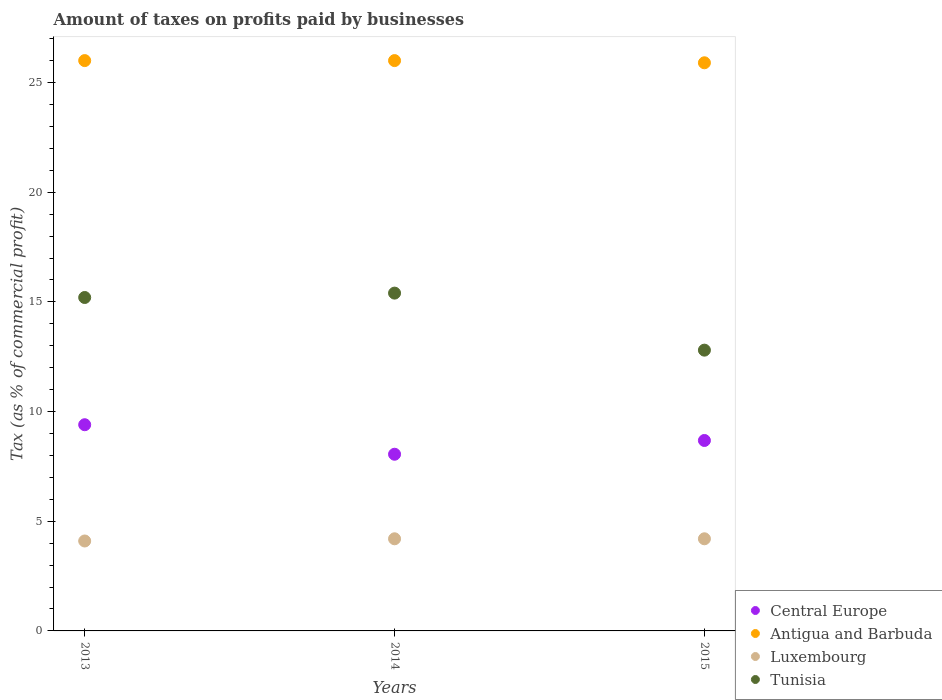What is the percentage of taxes paid by businesses in Central Europe in 2014?
Offer a very short reply. 8.05. Across all years, what is the maximum percentage of taxes paid by businesses in Tunisia?
Provide a short and direct response. 15.4. Across all years, what is the minimum percentage of taxes paid by businesses in Tunisia?
Your answer should be compact. 12.8. In which year was the percentage of taxes paid by businesses in Antigua and Barbuda minimum?
Keep it short and to the point. 2015. What is the difference between the percentage of taxes paid by businesses in Antigua and Barbuda in 2014 and that in 2015?
Your response must be concise. 0.1. What is the difference between the percentage of taxes paid by businesses in Tunisia in 2013 and the percentage of taxes paid by businesses in Central Europe in 2014?
Keep it short and to the point. 7.15. What is the average percentage of taxes paid by businesses in Luxembourg per year?
Offer a terse response. 4.17. In the year 2015, what is the difference between the percentage of taxes paid by businesses in Tunisia and percentage of taxes paid by businesses in Luxembourg?
Make the answer very short. 8.6. What is the ratio of the percentage of taxes paid by businesses in Tunisia in 2014 to that in 2015?
Your response must be concise. 1.2. Is the percentage of taxes paid by businesses in Antigua and Barbuda in 2014 less than that in 2015?
Ensure brevity in your answer.  No. Is the difference between the percentage of taxes paid by businesses in Tunisia in 2014 and 2015 greater than the difference between the percentage of taxes paid by businesses in Luxembourg in 2014 and 2015?
Your response must be concise. Yes. What is the difference between the highest and the lowest percentage of taxes paid by businesses in Tunisia?
Make the answer very short. 2.6. In how many years, is the percentage of taxes paid by businesses in Luxembourg greater than the average percentage of taxes paid by businesses in Luxembourg taken over all years?
Make the answer very short. 2. Is it the case that in every year, the sum of the percentage of taxes paid by businesses in Antigua and Barbuda and percentage of taxes paid by businesses in Luxembourg  is greater than the percentage of taxes paid by businesses in Central Europe?
Provide a short and direct response. Yes. Does the percentage of taxes paid by businesses in Central Europe monotonically increase over the years?
Make the answer very short. No. Is the percentage of taxes paid by businesses in Tunisia strictly greater than the percentage of taxes paid by businesses in Antigua and Barbuda over the years?
Your answer should be compact. No. How many dotlines are there?
Provide a succinct answer. 4. How many years are there in the graph?
Offer a very short reply. 3. What is the difference between two consecutive major ticks on the Y-axis?
Your response must be concise. 5. How are the legend labels stacked?
Provide a short and direct response. Vertical. What is the title of the graph?
Ensure brevity in your answer.  Amount of taxes on profits paid by businesses. What is the label or title of the Y-axis?
Provide a succinct answer. Tax (as % of commercial profit). What is the Tax (as % of commercial profit) in Central Europe in 2013?
Provide a succinct answer. 9.4. What is the Tax (as % of commercial profit) in Antigua and Barbuda in 2013?
Keep it short and to the point. 26. What is the Tax (as % of commercial profit) of Central Europe in 2014?
Keep it short and to the point. 8.05. What is the Tax (as % of commercial profit) of Antigua and Barbuda in 2014?
Offer a terse response. 26. What is the Tax (as % of commercial profit) of Luxembourg in 2014?
Make the answer very short. 4.2. What is the Tax (as % of commercial profit) of Tunisia in 2014?
Ensure brevity in your answer.  15.4. What is the Tax (as % of commercial profit) of Central Europe in 2015?
Your answer should be very brief. 8.68. What is the Tax (as % of commercial profit) of Antigua and Barbuda in 2015?
Offer a terse response. 25.9. What is the Tax (as % of commercial profit) in Luxembourg in 2015?
Offer a very short reply. 4.2. What is the Tax (as % of commercial profit) in Tunisia in 2015?
Provide a succinct answer. 12.8. Across all years, what is the maximum Tax (as % of commercial profit) in Antigua and Barbuda?
Keep it short and to the point. 26. Across all years, what is the minimum Tax (as % of commercial profit) of Central Europe?
Keep it short and to the point. 8.05. Across all years, what is the minimum Tax (as % of commercial profit) of Antigua and Barbuda?
Make the answer very short. 25.9. Across all years, what is the minimum Tax (as % of commercial profit) of Luxembourg?
Your answer should be very brief. 4.1. What is the total Tax (as % of commercial profit) in Central Europe in the graph?
Offer a very short reply. 26.14. What is the total Tax (as % of commercial profit) in Antigua and Barbuda in the graph?
Provide a succinct answer. 77.9. What is the total Tax (as % of commercial profit) of Tunisia in the graph?
Your answer should be compact. 43.4. What is the difference between the Tax (as % of commercial profit) in Central Europe in 2013 and that in 2014?
Offer a very short reply. 1.35. What is the difference between the Tax (as % of commercial profit) of Antigua and Barbuda in 2013 and that in 2014?
Give a very brief answer. 0. What is the difference between the Tax (as % of commercial profit) in Luxembourg in 2013 and that in 2014?
Your answer should be very brief. -0.1. What is the difference between the Tax (as % of commercial profit) in Tunisia in 2013 and that in 2014?
Offer a terse response. -0.2. What is the difference between the Tax (as % of commercial profit) of Central Europe in 2013 and that in 2015?
Your answer should be very brief. 0.72. What is the difference between the Tax (as % of commercial profit) in Luxembourg in 2013 and that in 2015?
Provide a succinct answer. -0.1. What is the difference between the Tax (as % of commercial profit) of Central Europe in 2014 and that in 2015?
Provide a succinct answer. -0.63. What is the difference between the Tax (as % of commercial profit) of Tunisia in 2014 and that in 2015?
Your answer should be compact. 2.6. What is the difference between the Tax (as % of commercial profit) in Central Europe in 2013 and the Tax (as % of commercial profit) in Antigua and Barbuda in 2014?
Make the answer very short. -16.6. What is the difference between the Tax (as % of commercial profit) of Central Europe in 2013 and the Tax (as % of commercial profit) of Luxembourg in 2014?
Keep it short and to the point. 5.2. What is the difference between the Tax (as % of commercial profit) in Antigua and Barbuda in 2013 and the Tax (as % of commercial profit) in Luxembourg in 2014?
Provide a short and direct response. 21.8. What is the difference between the Tax (as % of commercial profit) of Antigua and Barbuda in 2013 and the Tax (as % of commercial profit) of Tunisia in 2014?
Make the answer very short. 10.6. What is the difference between the Tax (as % of commercial profit) in Luxembourg in 2013 and the Tax (as % of commercial profit) in Tunisia in 2014?
Provide a short and direct response. -11.3. What is the difference between the Tax (as % of commercial profit) in Central Europe in 2013 and the Tax (as % of commercial profit) in Antigua and Barbuda in 2015?
Offer a terse response. -16.5. What is the difference between the Tax (as % of commercial profit) of Central Europe in 2013 and the Tax (as % of commercial profit) of Tunisia in 2015?
Provide a succinct answer. -3.4. What is the difference between the Tax (as % of commercial profit) of Antigua and Barbuda in 2013 and the Tax (as % of commercial profit) of Luxembourg in 2015?
Offer a very short reply. 21.8. What is the difference between the Tax (as % of commercial profit) of Luxembourg in 2013 and the Tax (as % of commercial profit) of Tunisia in 2015?
Your answer should be very brief. -8.7. What is the difference between the Tax (as % of commercial profit) of Central Europe in 2014 and the Tax (as % of commercial profit) of Antigua and Barbuda in 2015?
Ensure brevity in your answer.  -17.85. What is the difference between the Tax (as % of commercial profit) of Central Europe in 2014 and the Tax (as % of commercial profit) of Luxembourg in 2015?
Give a very brief answer. 3.85. What is the difference between the Tax (as % of commercial profit) of Central Europe in 2014 and the Tax (as % of commercial profit) of Tunisia in 2015?
Keep it short and to the point. -4.75. What is the difference between the Tax (as % of commercial profit) in Antigua and Barbuda in 2014 and the Tax (as % of commercial profit) in Luxembourg in 2015?
Ensure brevity in your answer.  21.8. What is the difference between the Tax (as % of commercial profit) of Luxembourg in 2014 and the Tax (as % of commercial profit) of Tunisia in 2015?
Make the answer very short. -8.6. What is the average Tax (as % of commercial profit) of Central Europe per year?
Your response must be concise. 8.71. What is the average Tax (as % of commercial profit) in Antigua and Barbuda per year?
Your answer should be compact. 25.97. What is the average Tax (as % of commercial profit) in Luxembourg per year?
Give a very brief answer. 4.17. What is the average Tax (as % of commercial profit) of Tunisia per year?
Offer a very short reply. 14.47. In the year 2013, what is the difference between the Tax (as % of commercial profit) of Central Europe and Tax (as % of commercial profit) of Antigua and Barbuda?
Your answer should be very brief. -16.6. In the year 2013, what is the difference between the Tax (as % of commercial profit) of Antigua and Barbuda and Tax (as % of commercial profit) of Luxembourg?
Make the answer very short. 21.9. In the year 2013, what is the difference between the Tax (as % of commercial profit) of Antigua and Barbuda and Tax (as % of commercial profit) of Tunisia?
Offer a terse response. 10.8. In the year 2014, what is the difference between the Tax (as % of commercial profit) in Central Europe and Tax (as % of commercial profit) in Antigua and Barbuda?
Offer a very short reply. -17.95. In the year 2014, what is the difference between the Tax (as % of commercial profit) of Central Europe and Tax (as % of commercial profit) of Luxembourg?
Your response must be concise. 3.85. In the year 2014, what is the difference between the Tax (as % of commercial profit) in Central Europe and Tax (as % of commercial profit) in Tunisia?
Provide a short and direct response. -7.35. In the year 2014, what is the difference between the Tax (as % of commercial profit) of Antigua and Barbuda and Tax (as % of commercial profit) of Luxembourg?
Provide a succinct answer. 21.8. In the year 2014, what is the difference between the Tax (as % of commercial profit) of Luxembourg and Tax (as % of commercial profit) of Tunisia?
Offer a very short reply. -11.2. In the year 2015, what is the difference between the Tax (as % of commercial profit) in Central Europe and Tax (as % of commercial profit) in Antigua and Barbuda?
Your response must be concise. -17.22. In the year 2015, what is the difference between the Tax (as % of commercial profit) of Central Europe and Tax (as % of commercial profit) of Luxembourg?
Your response must be concise. 4.48. In the year 2015, what is the difference between the Tax (as % of commercial profit) in Central Europe and Tax (as % of commercial profit) in Tunisia?
Your answer should be compact. -4.12. In the year 2015, what is the difference between the Tax (as % of commercial profit) in Antigua and Barbuda and Tax (as % of commercial profit) in Luxembourg?
Offer a very short reply. 21.7. In the year 2015, what is the difference between the Tax (as % of commercial profit) of Antigua and Barbuda and Tax (as % of commercial profit) of Tunisia?
Your response must be concise. 13.1. What is the ratio of the Tax (as % of commercial profit) of Central Europe in 2013 to that in 2014?
Your response must be concise. 1.17. What is the ratio of the Tax (as % of commercial profit) of Luxembourg in 2013 to that in 2014?
Your response must be concise. 0.98. What is the ratio of the Tax (as % of commercial profit) in Central Europe in 2013 to that in 2015?
Ensure brevity in your answer.  1.08. What is the ratio of the Tax (as % of commercial profit) in Antigua and Barbuda in 2013 to that in 2015?
Your response must be concise. 1. What is the ratio of the Tax (as % of commercial profit) in Luxembourg in 2013 to that in 2015?
Provide a short and direct response. 0.98. What is the ratio of the Tax (as % of commercial profit) in Tunisia in 2013 to that in 2015?
Provide a short and direct response. 1.19. What is the ratio of the Tax (as % of commercial profit) of Central Europe in 2014 to that in 2015?
Give a very brief answer. 0.93. What is the ratio of the Tax (as % of commercial profit) of Tunisia in 2014 to that in 2015?
Make the answer very short. 1.2. What is the difference between the highest and the second highest Tax (as % of commercial profit) of Central Europe?
Your answer should be very brief. 0.72. What is the difference between the highest and the second highest Tax (as % of commercial profit) of Antigua and Barbuda?
Give a very brief answer. 0. What is the difference between the highest and the second highest Tax (as % of commercial profit) in Tunisia?
Your response must be concise. 0.2. What is the difference between the highest and the lowest Tax (as % of commercial profit) in Central Europe?
Ensure brevity in your answer.  1.35. What is the difference between the highest and the lowest Tax (as % of commercial profit) in Antigua and Barbuda?
Give a very brief answer. 0.1. What is the difference between the highest and the lowest Tax (as % of commercial profit) in Luxembourg?
Give a very brief answer. 0.1. What is the difference between the highest and the lowest Tax (as % of commercial profit) in Tunisia?
Your response must be concise. 2.6. 